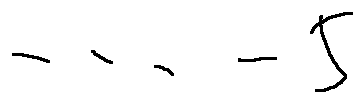<formula> <loc_0><loc_0><loc_500><loc_500>\cdots - 5</formula> 